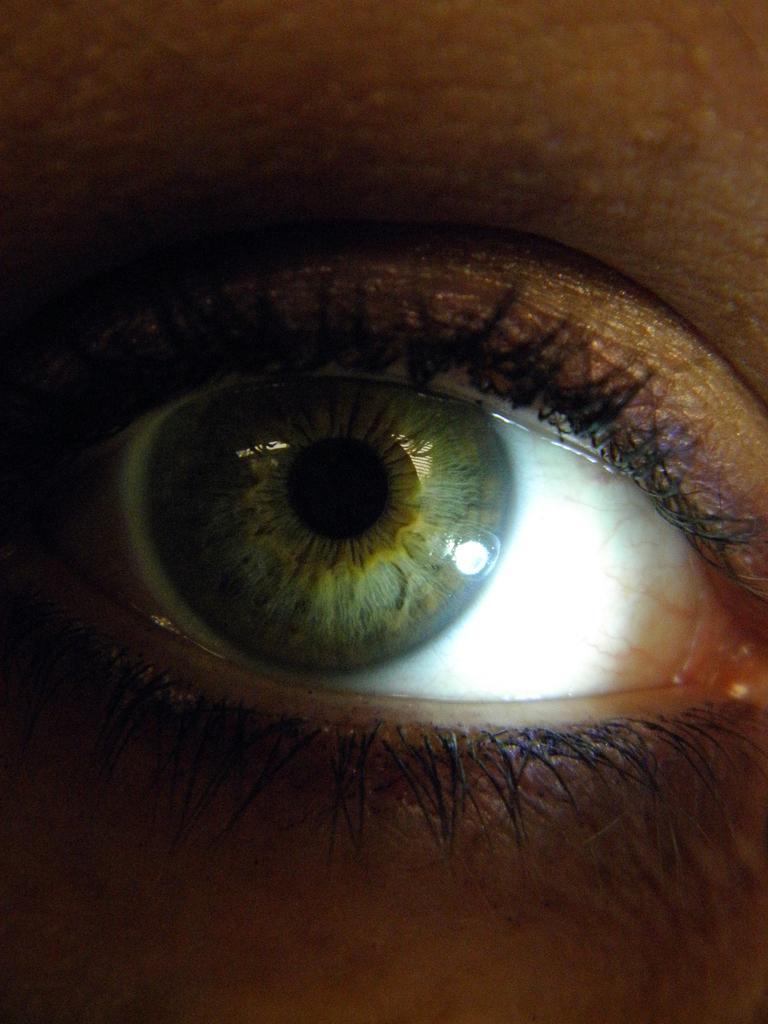Can you describe this image briefly? In this image we can see a person's eye. 